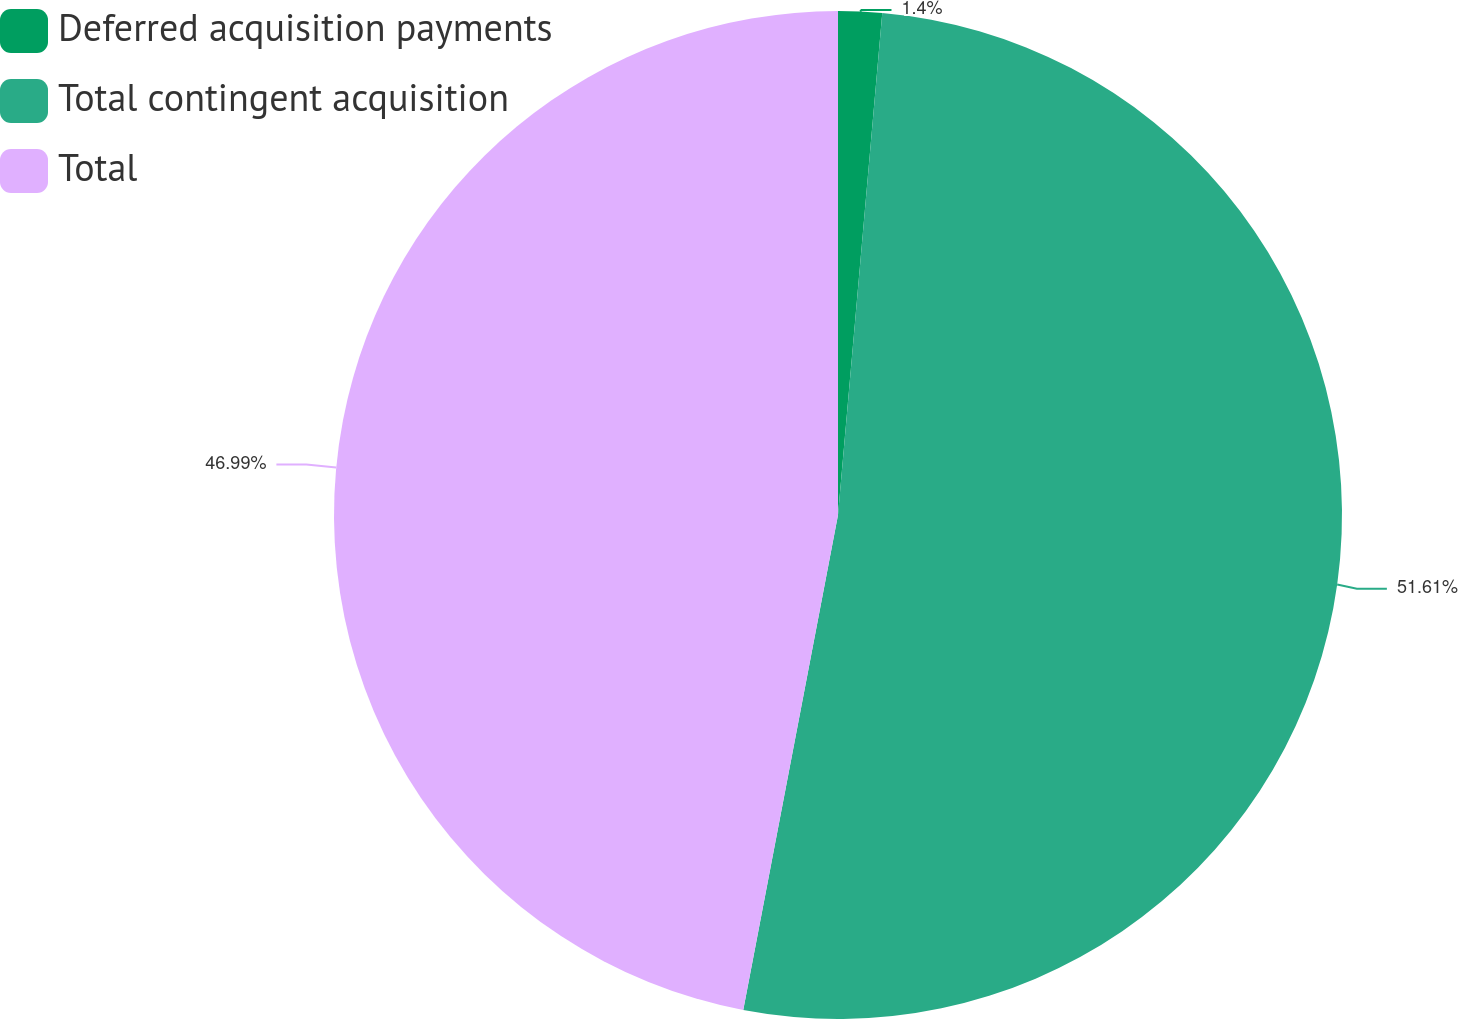Convert chart. <chart><loc_0><loc_0><loc_500><loc_500><pie_chart><fcel>Deferred acquisition payments<fcel>Total contingent acquisition<fcel>Total<nl><fcel>1.4%<fcel>51.61%<fcel>46.99%<nl></chart> 